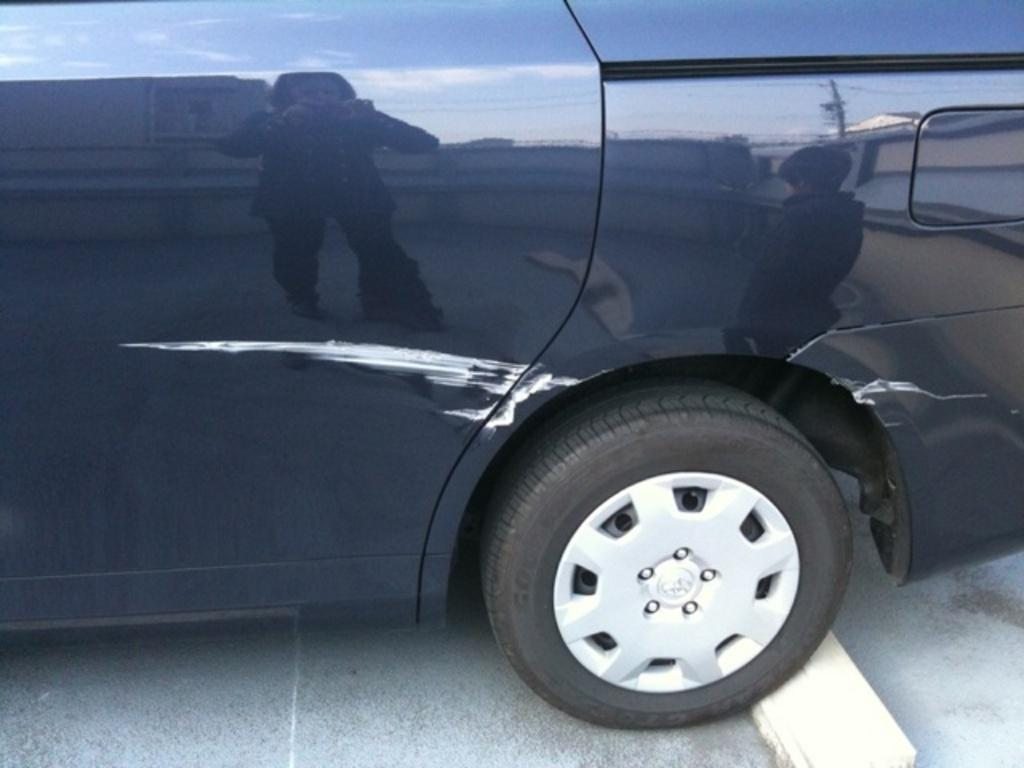What color is the vehicle in the image? The vehicle is blue. Can you describe any notable features of the vehicle? Yes, there is a scratch on the vehicle. What type of quarter is visible in the image? There is no quarter present in the image. What town is the vehicle located in the image? The image does not provide information about the town where the vehicle is located. 